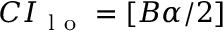Convert formula to latex. <formula><loc_0><loc_0><loc_500><loc_500>C I _ { l o } = [ B \alpha / 2 ]</formula> 